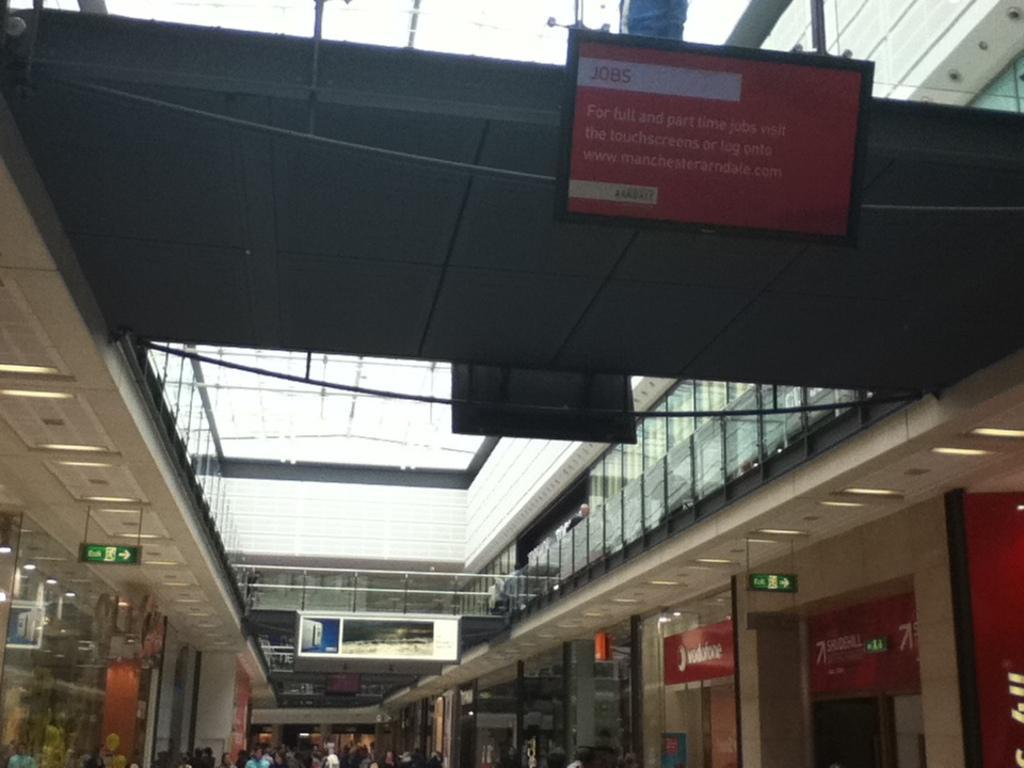Please provide a concise description of this image. As we can see in the image there is a building, few people here and there and on the top there is sky. Here there is a banner. 